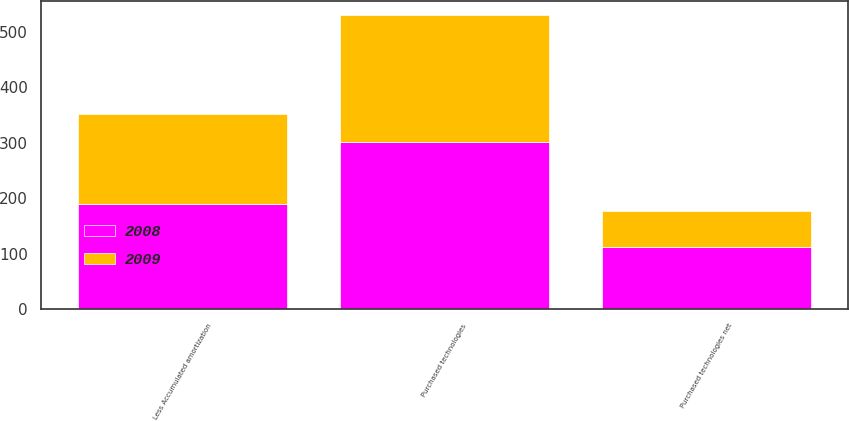Convert chart to OTSL. <chart><loc_0><loc_0><loc_500><loc_500><stacked_bar_chart><ecel><fcel>Purchased technologies<fcel>Less Accumulated amortization<fcel>Purchased technologies net<nl><fcel>2008<fcel>302.4<fcel>189.1<fcel>113.3<nl><fcel>2009<fcel>227.5<fcel>163.1<fcel>64.4<nl></chart> 